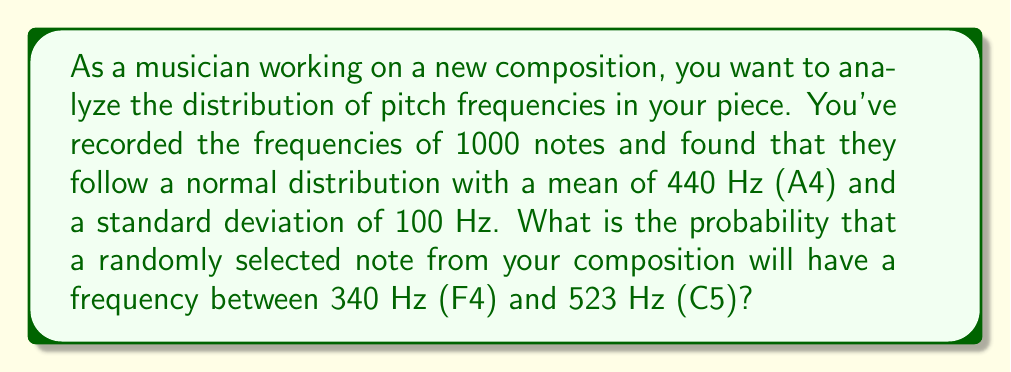Help me with this question. To solve this problem, we need to use the properties of the normal distribution and the concept of z-scores. Let's break it down step-by-step:

1. Given information:
   - Mean (μ) = 440 Hz
   - Standard deviation (σ) = 100 Hz
   - Lower bound = 340 Hz
   - Upper bound = 523 Hz

2. Calculate the z-scores for the lower and upper bounds:
   $$ z_1 = \frac{x_1 - \mu}{\sigma} = \frac{340 - 440}{100} = -1 $$
   $$ z_2 = \frac{x_2 - \mu}{\sigma} = \frac{523 - 440}{100} = 0.83 $$

3. The probability we're looking for is the area under the standard normal curve between z₁ and z₂. We can find this using the cumulative distribution function (CDF) of the standard normal distribution, often denoted as Φ(z).

4. The probability is:
   $$ P(340 < X < 523) = P(-1 < Z < 0.83) = \Phi(0.83) - \Phi(-1) $$

5. Using a standard normal table or calculator:
   $$ \Phi(0.83) \approx 0.7967 $$
   $$ \Phi(-1) \approx 0.1587 $$

6. Therefore, the probability is:
   $$ P(340 < X < 523) = 0.7967 - 0.1587 = 0.6380 $$

This means there's approximately a 63.80% chance that a randomly selected note from your composition will have a frequency between 340 Hz and 523 Hz.
Answer: 0.6380 or 63.80% 